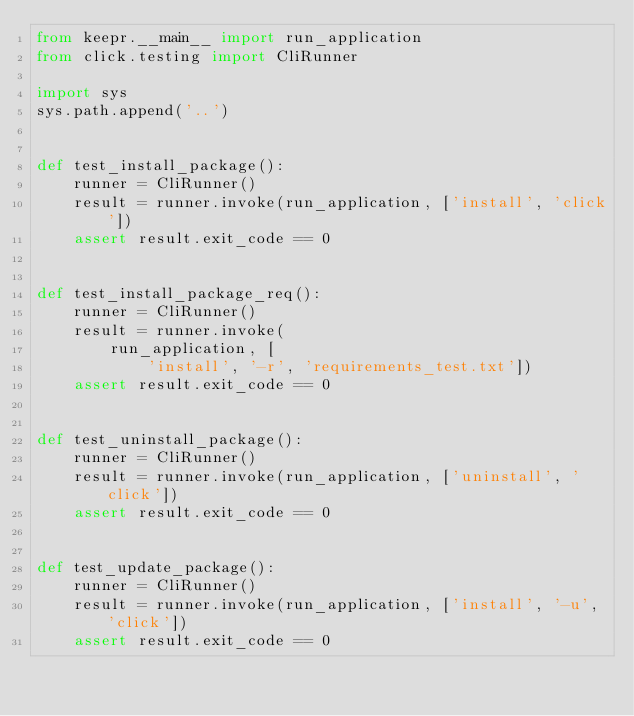<code> <loc_0><loc_0><loc_500><loc_500><_Python_>from keepr.__main__ import run_application
from click.testing import CliRunner

import sys
sys.path.append('..')


def test_install_package():
    runner = CliRunner()
    result = runner.invoke(run_application, ['install', 'click'])
    assert result.exit_code == 0


def test_install_package_req():
    runner = CliRunner()
    result = runner.invoke(
        run_application, [
            'install', '-r', 'requirements_test.txt'])
    assert result.exit_code == 0


def test_uninstall_package():
    runner = CliRunner()
    result = runner.invoke(run_application, ['uninstall', 'click'])
    assert result.exit_code == 0


def test_update_package():
    runner = CliRunner()
    result = runner.invoke(run_application, ['install', '-u', 'click'])
    assert result.exit_code == 0
</code> 